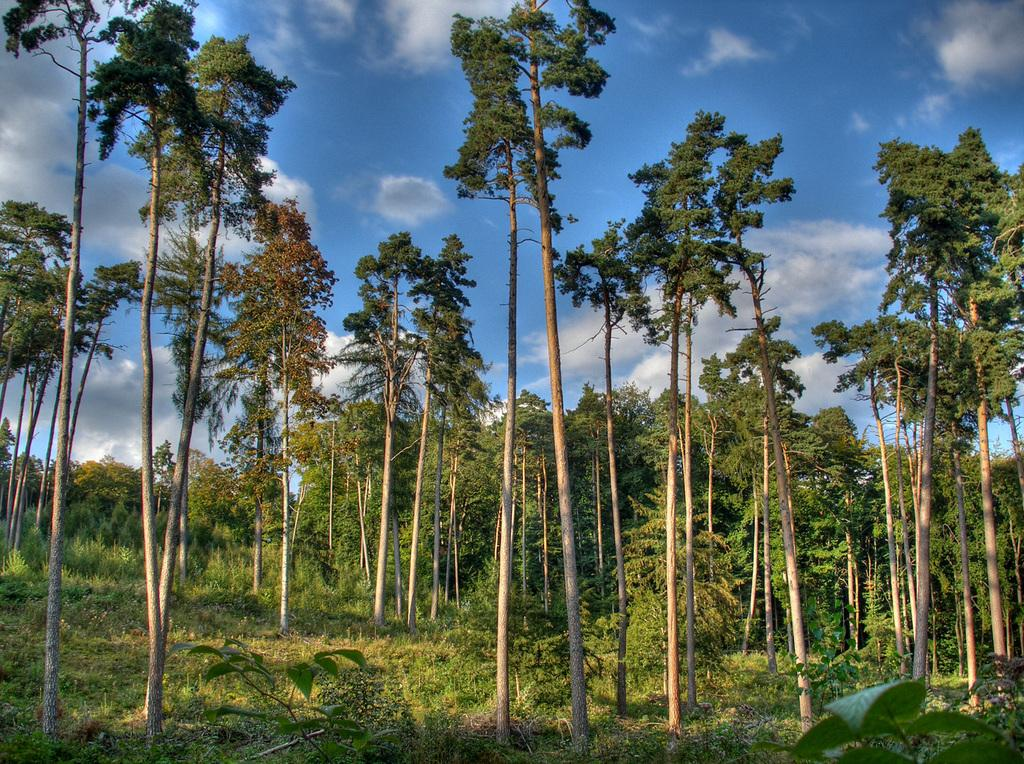What type of vegetation is present in the image? There are trees in the image. What type of ground cover is visible at the bottom of the image? There is grass at the bottom of the image. What part of the natural environment is visible at the top of the image? The sky is visible at the top of the image. How many dinosaurs can be seen grazing on the grass in the image? There are no dinosaurs present in the image; it features trees, grass, and the sky. What type of wing is visible on the trees in the image? There are no wings visible on the trees in the image; they are simply depicted as standing plants. 